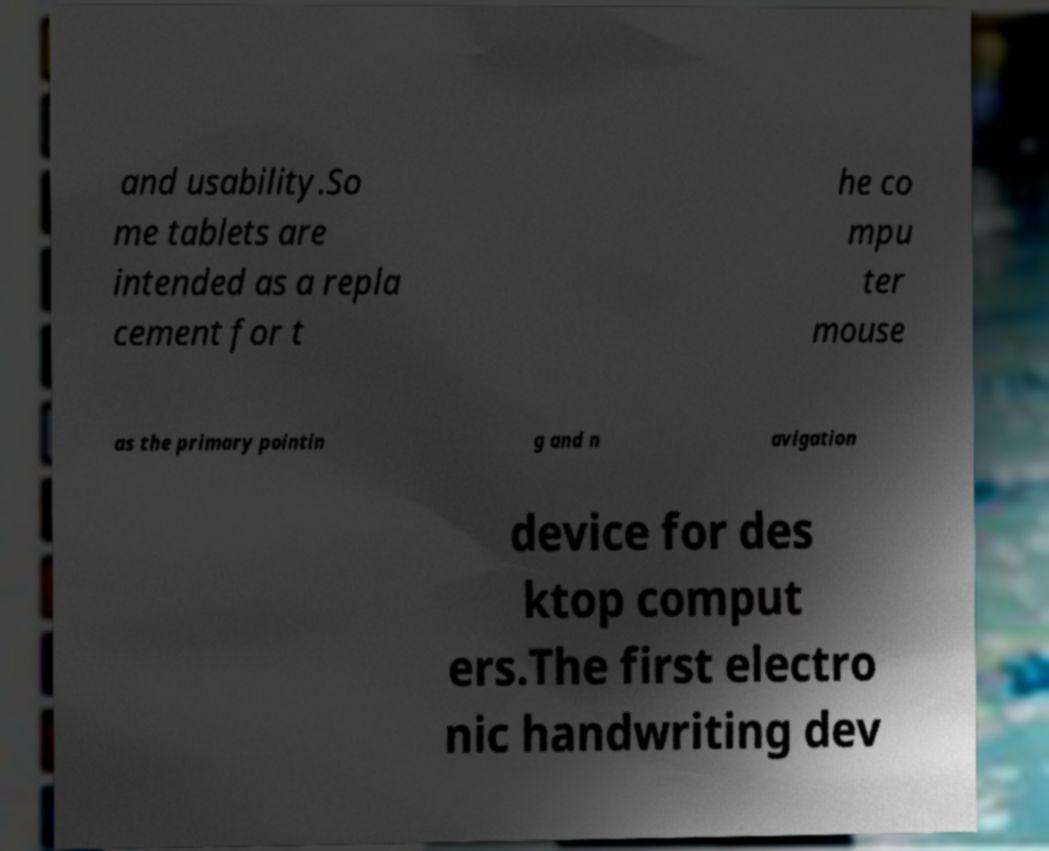Please read and relay the text visible in this image. What does it say? and usability.So me tablets are intended as a repla cement for t he co mpu ter mouse as the primary pointin g and n avigation device for des ktop comput ers.The first electro nic handwriting dev 